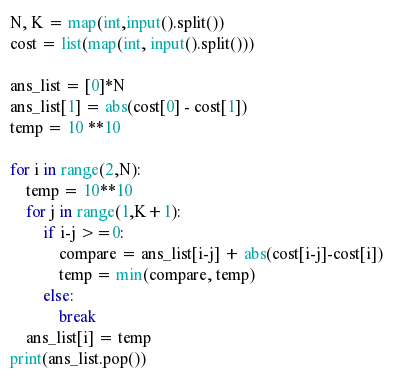Convert code to text. <code><loc_0><loc_0><loc_500><loc_500><_Python_>N, K = map(int,input().split())
cost = list(map(int, input().split()))

ans_list = [0]*N
ans_list[1] = abs(cost[0] - cost[1])
temp = 10 **10

for i in range(2,N):
    temp = 10**10
    for j in range(1,K+1):
        if i-j >=0:
            compare = ans_list[i-j] + abs(cost[i-j]-cost[i])
            temp = min(compare, temp)
        else:
            break
    ans_list[i] = temp
print(ans_list.pop())
</code> 